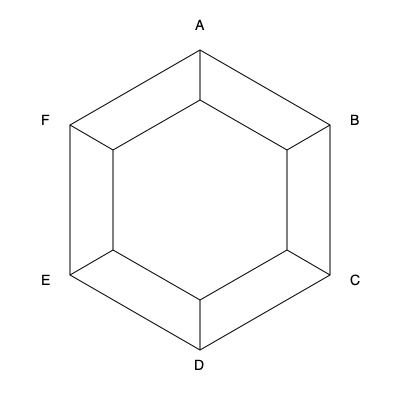The diagram shows two concentric hexagonal formations used by the Roman army. If the outer formation rotates 60° clockwise and the inner formation rotates 120° counterclockwise, which outer vertex will align with the inner vertex that was originally at position A? Let's approach this step-by-step:

1) First, we need to understand the initial positions:
   - The outer vertices are labeled A, B, C, D, E, F (clockwise from the top).
   - The inner vertices align with the outer ones initially.

2) The outer formation rotates 60° clockwise:
   - This is equivalent to one position in the clockwise direction.
   - A moves to where B was, B to C, C to D, and so on.
   - F ends up where A was originally.

3) The inner formation rotates 120° counterclockwise:
   - This is equivalent to two positions in the counterclockwise direction.
   - The inner vertex that was at A moves two positions counterclockwise.
   - It ends up where the inner vertex aligned with C was originally.

4) After these rotations:
   - The inner vertex that was originally at A is now where C was.
   - We need to find which outer vertex is now at this position.

5) From step 2, we know that D is now where C was originally.

Therefore, after the rotations, the outer vertex D will align with the inner vertex that was originally at position A.
Answer: D 